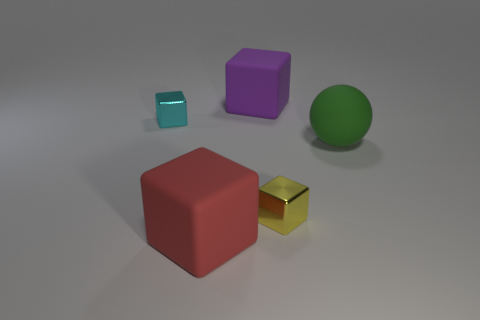Subtract all large red matte blocks. How many blocks are left? 3 Subtract all yellow blocks. How many blocks are left? 3 Add 1 tiny cyan cubes. How many objects exist? 6 Subtract all cubes. How many objects are left? 1 Subtract 3 blocks. How many blocks are left? 1 Subtract all yellow cubes. How many yellow balls are left? 0 Add 5 large cubes. How many large cubes exist? 7 Subtract 0 gray cylinders. How many objects are left? 5 Subtract all yellow balls. Subtract all brown cylinders. How many balls are left? 1 Subtract all large blocks. Subtract all yellow cubes. How many objects are left? 2 